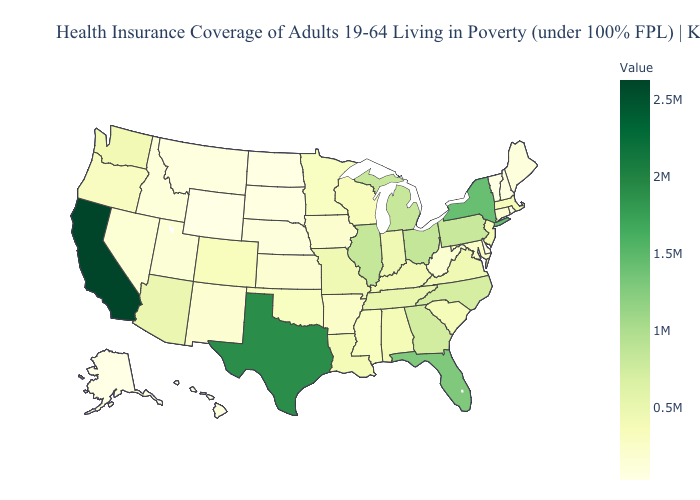Among the states that border Florida , which have the lowest value?
Write a very short answer. Alabama. Which states hav the highest value in the West?
Write a very short answer. California. Does Colorado have the lowest value in the USA?
Quick response, please. No. Among the states that border New York , which have the lowest value?
Answer briefly. Vermont. Is the legend a continuous bar?
Short answer required. Yes. Among the states that border Florida , which have the highest value?
Write a very short answer. Georgia. Which states have the highest value in the USA?
Concise answer only. California. 